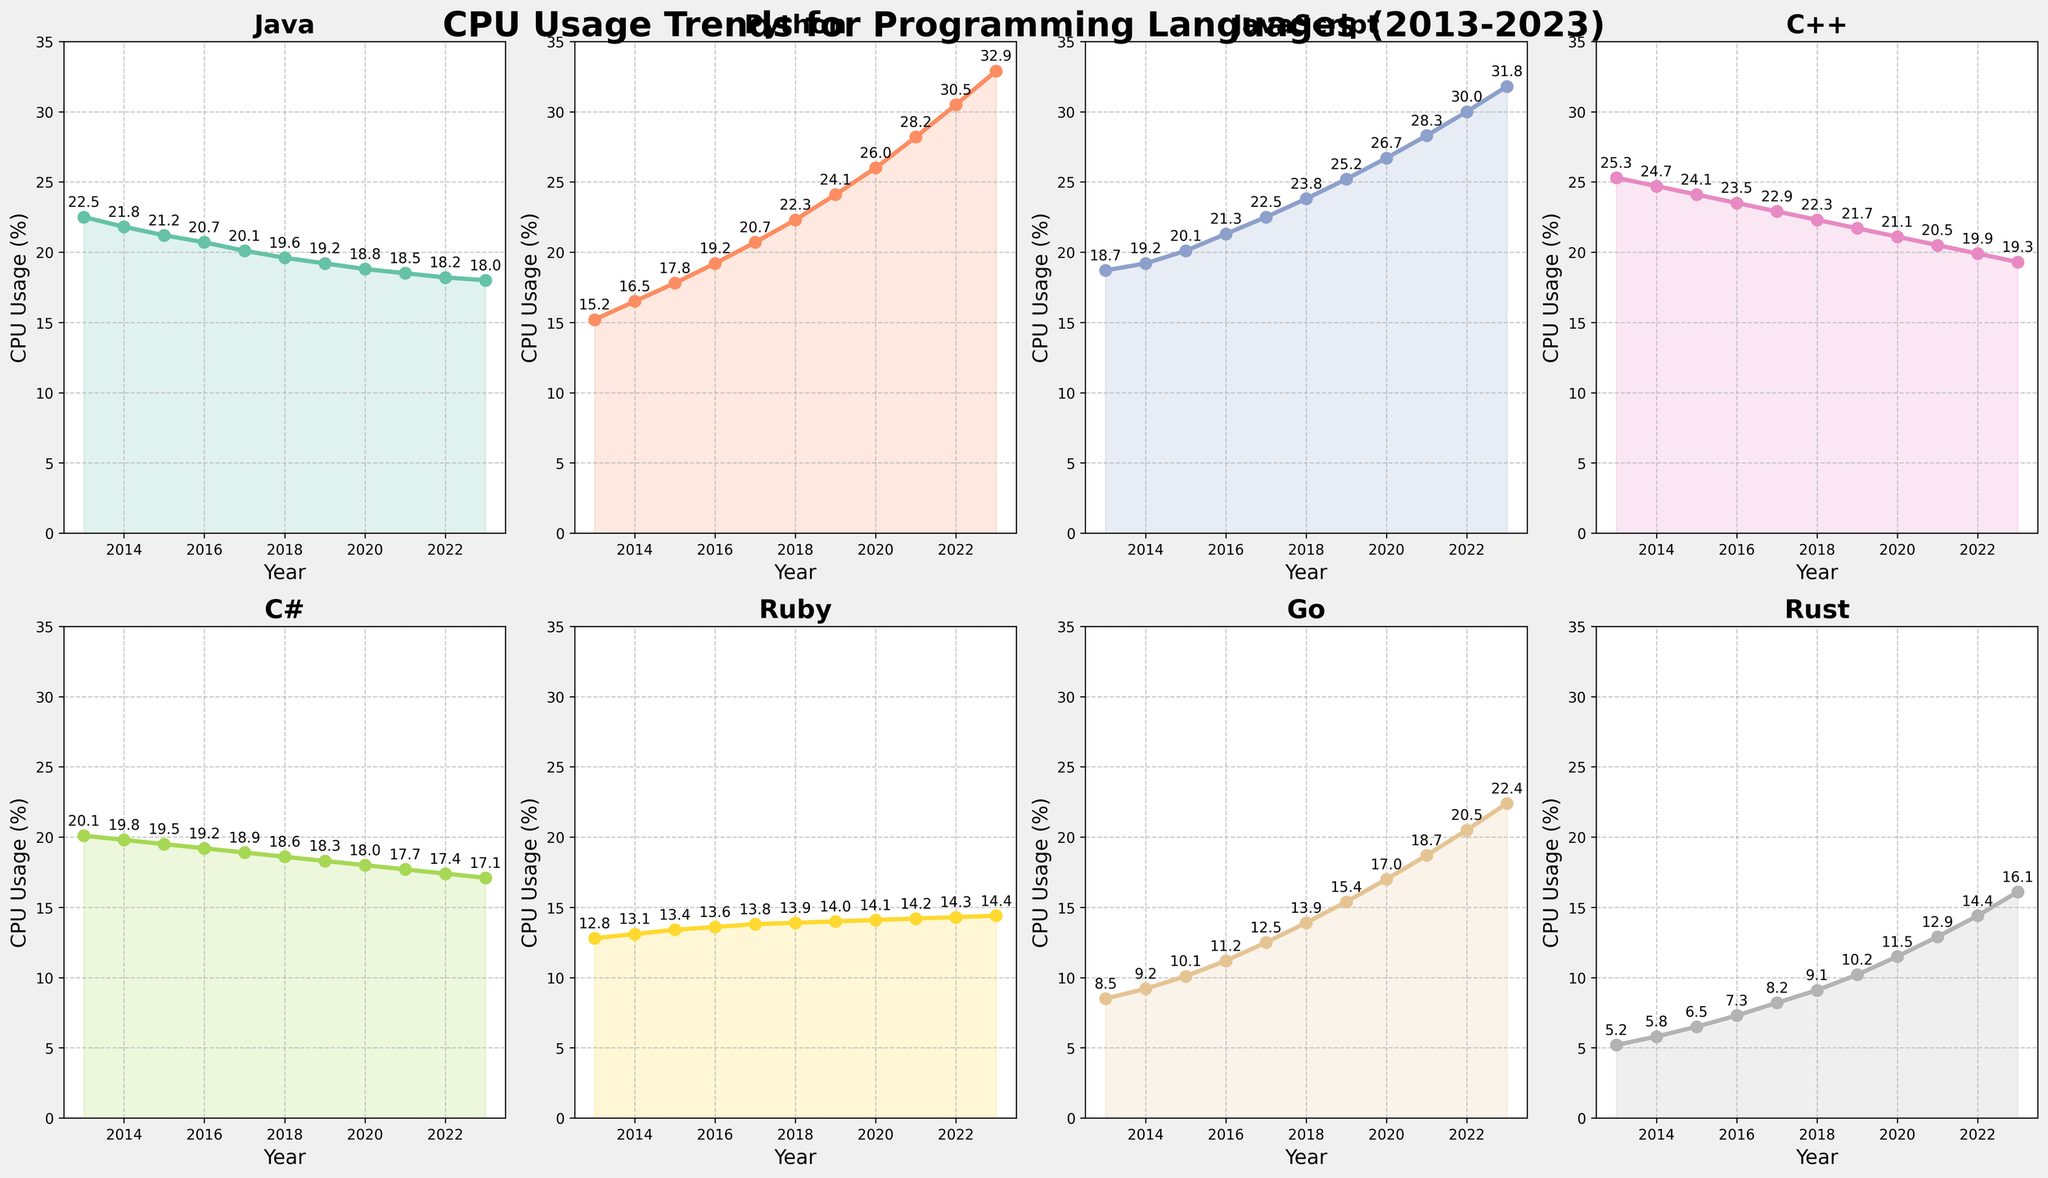Which programming language shows the highest CPU usage in 2023? The plot for each programming language shows their respective CPU usage over the years, and in the year 2023, Python has the highest value.
Answer: Python Which language had a consistent increase in CPU usage over all the years? By observing the plots, only Python consistently shows an upward trend in CPU usage every year from 2013 to 2023.
Answer: Python In what year did JavaScript's CPU usage first surpass Java's? Looking at the plots for JavaScript and Java, JavaScript first surpasses Java in the year 2016.
Answer: 2016 What is the combined CPU usage for Go and Rust in 2020? From the plot, Go's usage in 2020 is 17.0% and Rust's usage is 11.5%. Adding these values, 17.0 + 11.5 equals 28.5%.
Answer: 28.5% Compare the CPU usage trends of Ruby and C# from 2013 to 2023. Does one show a clear increasing or decreasing trend? Observing the plots, Ruby's CPU usage remains fairly stable with minor increases, while C# shows a slight declining trend over the years.
Answer: Ruby stable, C# declining Which programming language had the sharpest increase in CPU usage from 2013 to 2023? By calculating the differences, Python increased from 15.2% in 2013 to 32.9% in 2023, which is an increase of 17.7%, the highest among all languages.
Answer: Python In what year did Go see a notable increase in CPU usage compared to the previous year? The plot indicates that Go saw notable increases in several years, but the largest increase occurred between 2017 and 2018 (12.5% to 13.9%).
Answer: 2018 Which two programming languages had almost parallel trends from 2013 to 2023? From the plots, Java and C# show trends that are almost parallel, both starting high and decreasing slowly over the years.
Answer: Java and C# For the year 2022, what is the average CPU usage of all programming languages combined? Summing up the CPU usage percentages for all languages in 2022: 18.2 + 30.5 + 30.0 + 19.9 + 17.4 + 14.3 + 20.5 + 14.4 equals 165.2%. Dividing by 8 languages, the average is 165.2 / 8 = 20.65%.
Answer: 20.65% Which language showed the highest peak in CPU usage over the decade? Observing the peaks in each subplot, Python reached the highest peak in 2023 with 32.9%.
Answer: Python 